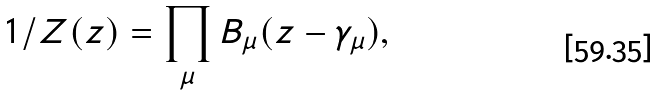<formula> <loc_0><loc_0><loc_500><loc_500>1 / Z ( z ) = \prod _ { \mu } B _ { \mu } ( z - \gamma _ { \mu } ) ,</formula> 